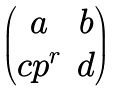Convert formula to latex. <formula><loc_0><loc_0><loc_500><loc_500>\begin{pmatrix} a & b \\ c p ^ { r } & d \end{pmatrix}</formula> 